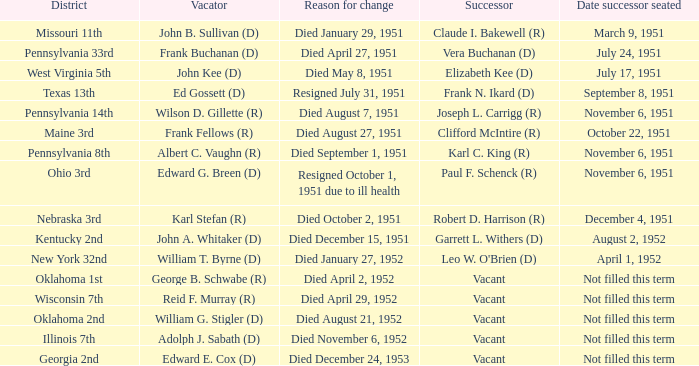How many vacators were present in the pennsylvania 33rd district? 1.0. 